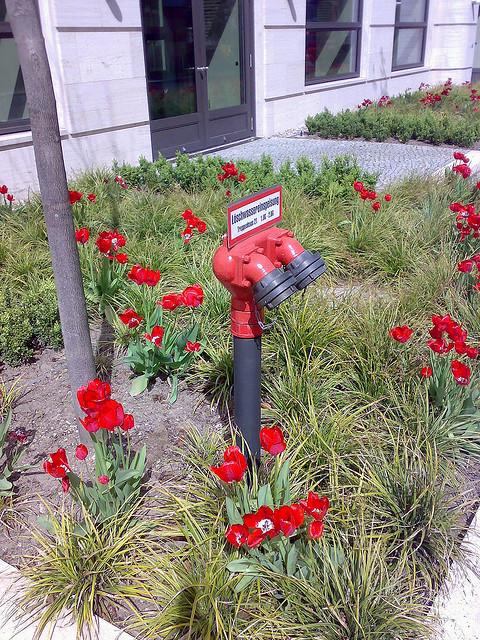What is that red metal thing in the ground?
Be succinct. Hydrant. Which color are the flowers?
Write a very short answer. Red. How many windows can be seen on the building?
Answer briefly. 3. 